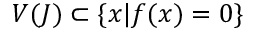Convert formula to latex. <formula><loc_0><loc_0><loc_500><loc_500>V ( J ) \subset \{ x | f ( x ) = 0 \}</formula> 